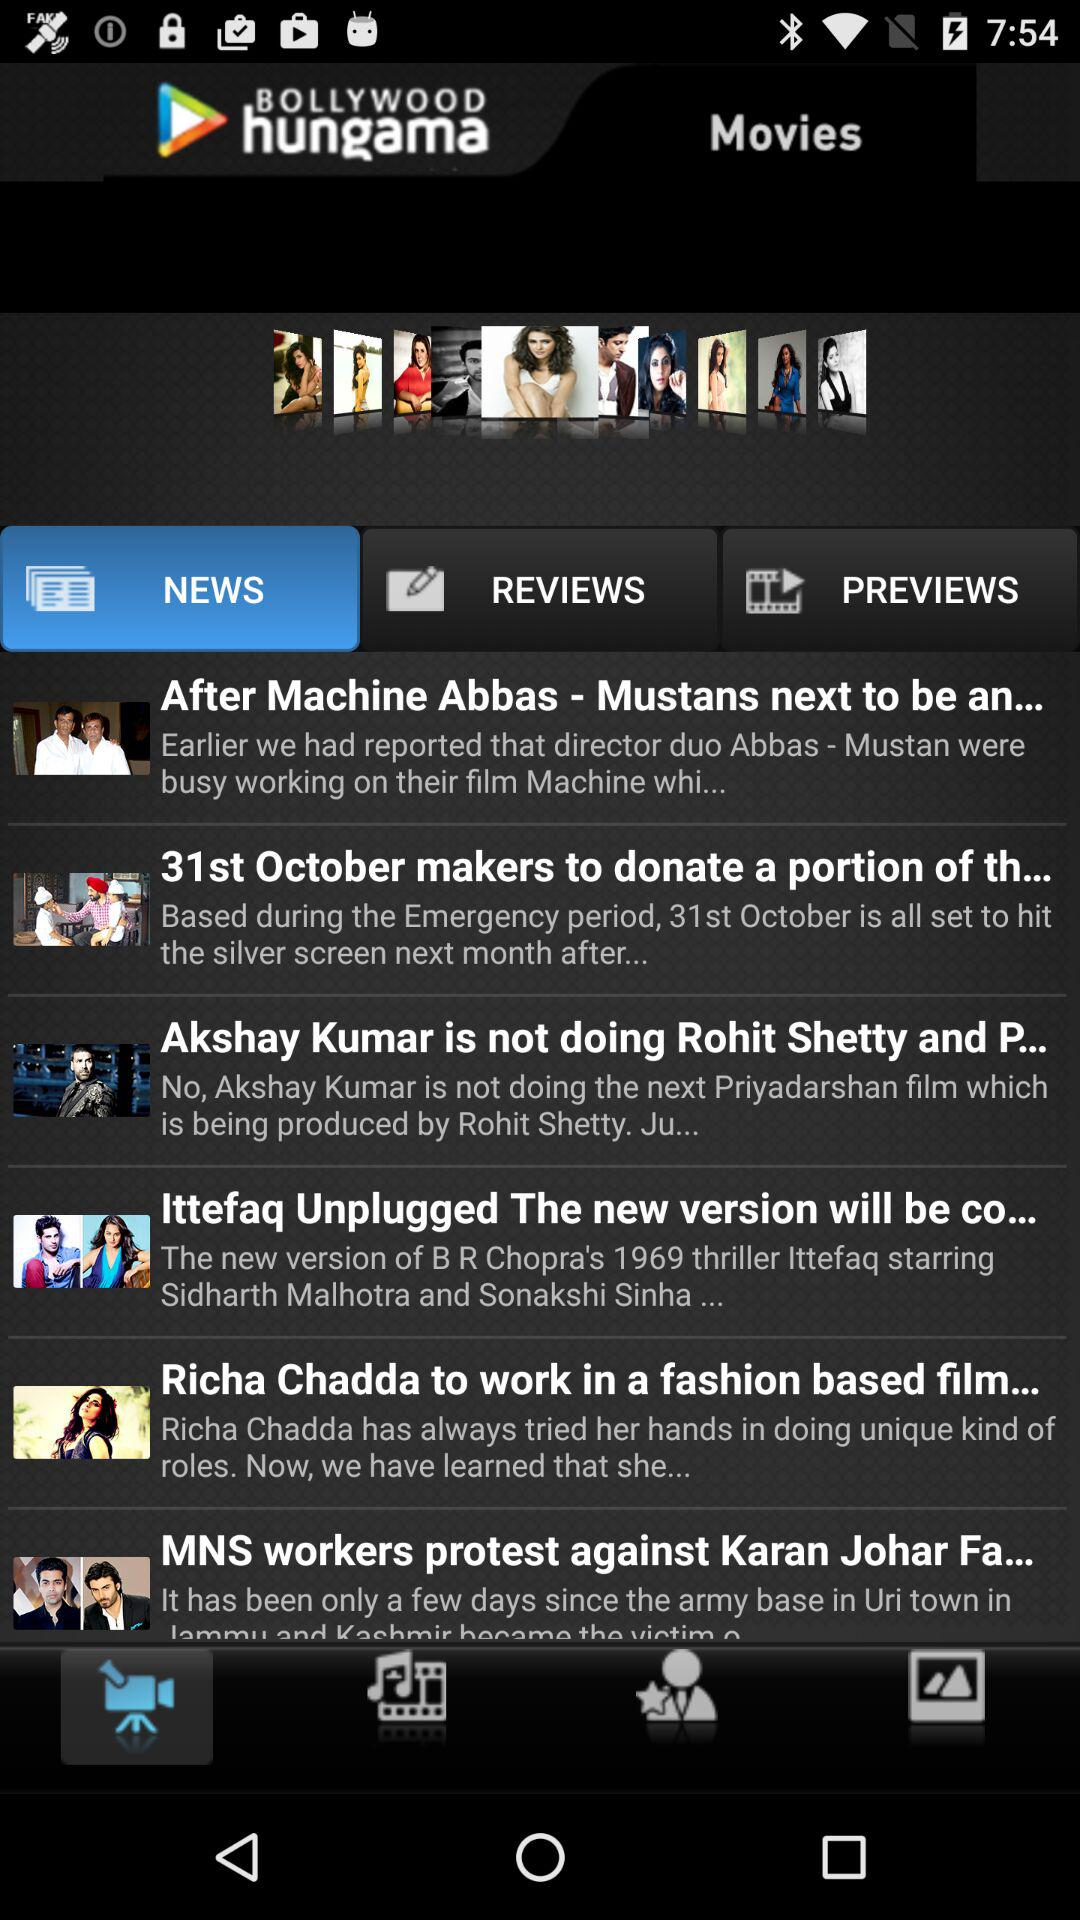What is the app title? The app title is "BOLLYWOOD hungama". 